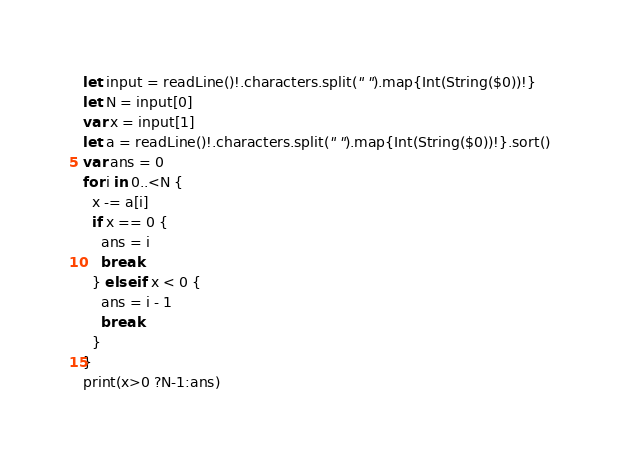Convert code to text. <code><loc_0><loc_0><loc_500><loc_500><_Swift_>let input = readLine()!.characters.split(" ").map{Int(String($0))!}
let N = input[0]
var x = input[1]
let a = readLine()!.characters.split(" ").map{Int(String($0))!}.sort()
var ans = 0
for i in 0..<N {
  x -= a[i]
  if x == 0 {
    ans = i
    break
  } else if x < 0 {
    ans = i - 1
    break
  }
}
print(x>0 ?N-1:ans)</code> 